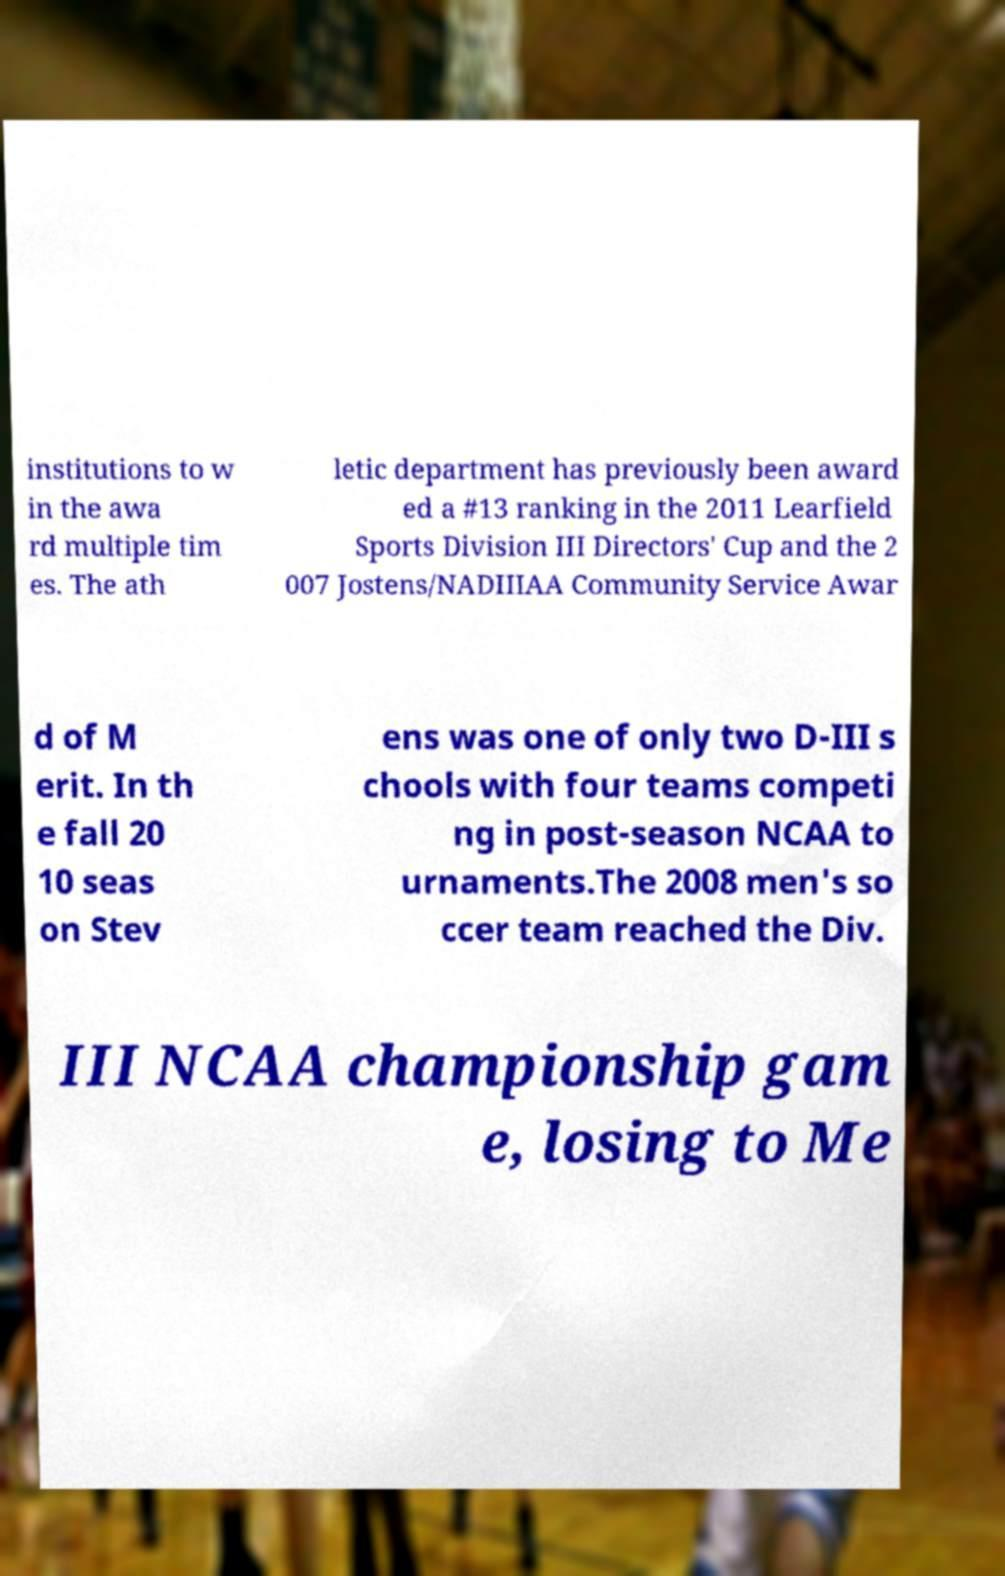Please identify and transcribe the text found in this image. institutions to w in the awa rd multiple tim es. The ath letic department has previously been award ed a #13 ranking in the 2011 Learfield Sports Division III Directors' Cup and the 2 007 Jostens/NADIIIAA Community Service Awar d of M erit. In th e fall 20 10 seas on Stev ens was one of only two D-III s chools with four teams competi ng in post-season NCAA to urnaments.The 2008 men's so ccer team reached the Div. III NCAA championship gam e, losing to Me 